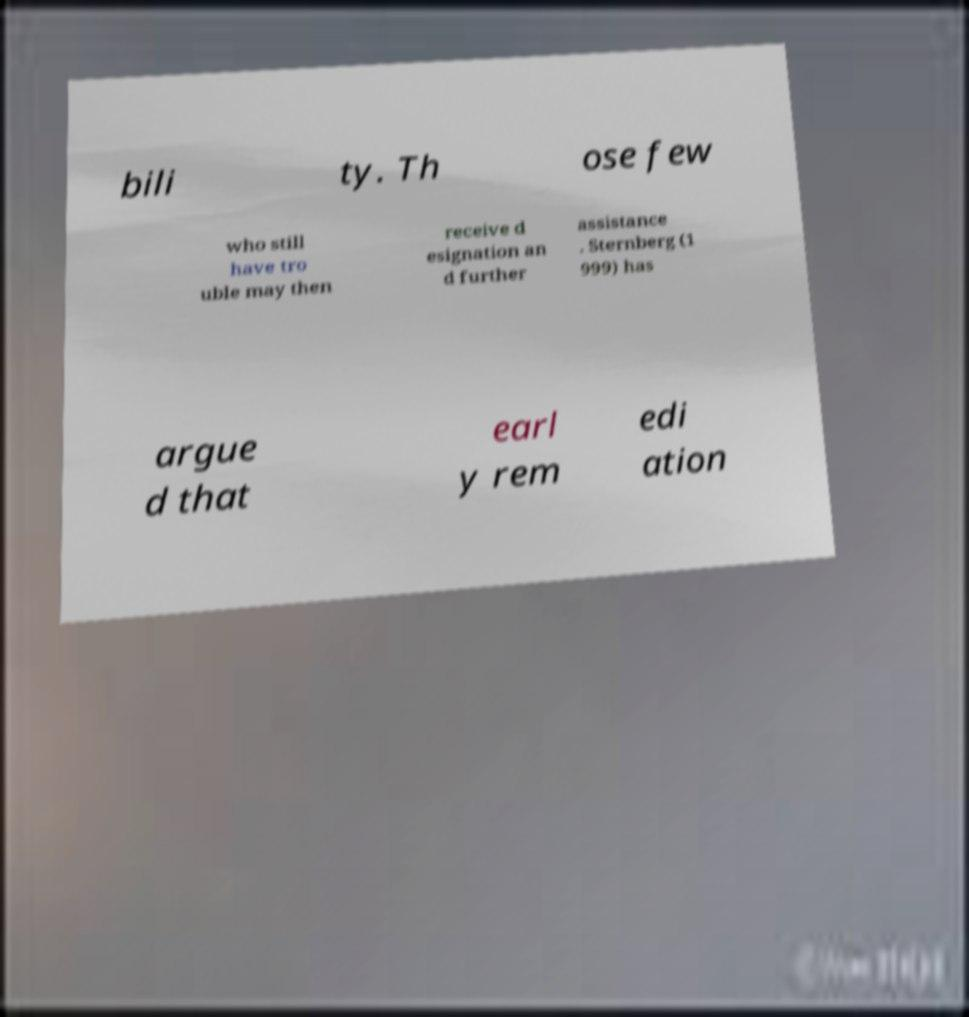Please identify and transcribe the text found in this image. bili ty. Th ose few who still have tro uble may then receive d esignation an d further assistance . Sternberg (1 999) has argue d that earl y rem edi ation 